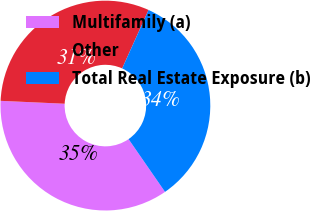Convert chart. <chart><loc_0><loc_0><loc_500><loc_500><pie_chart><fcel>Multifamily (a)<fcel>Other<fcel>Total Real Estate Exposure (b)<nl><fcel>35.34%<fcel>31.03%<fcel>33.62%<nl></chart> 